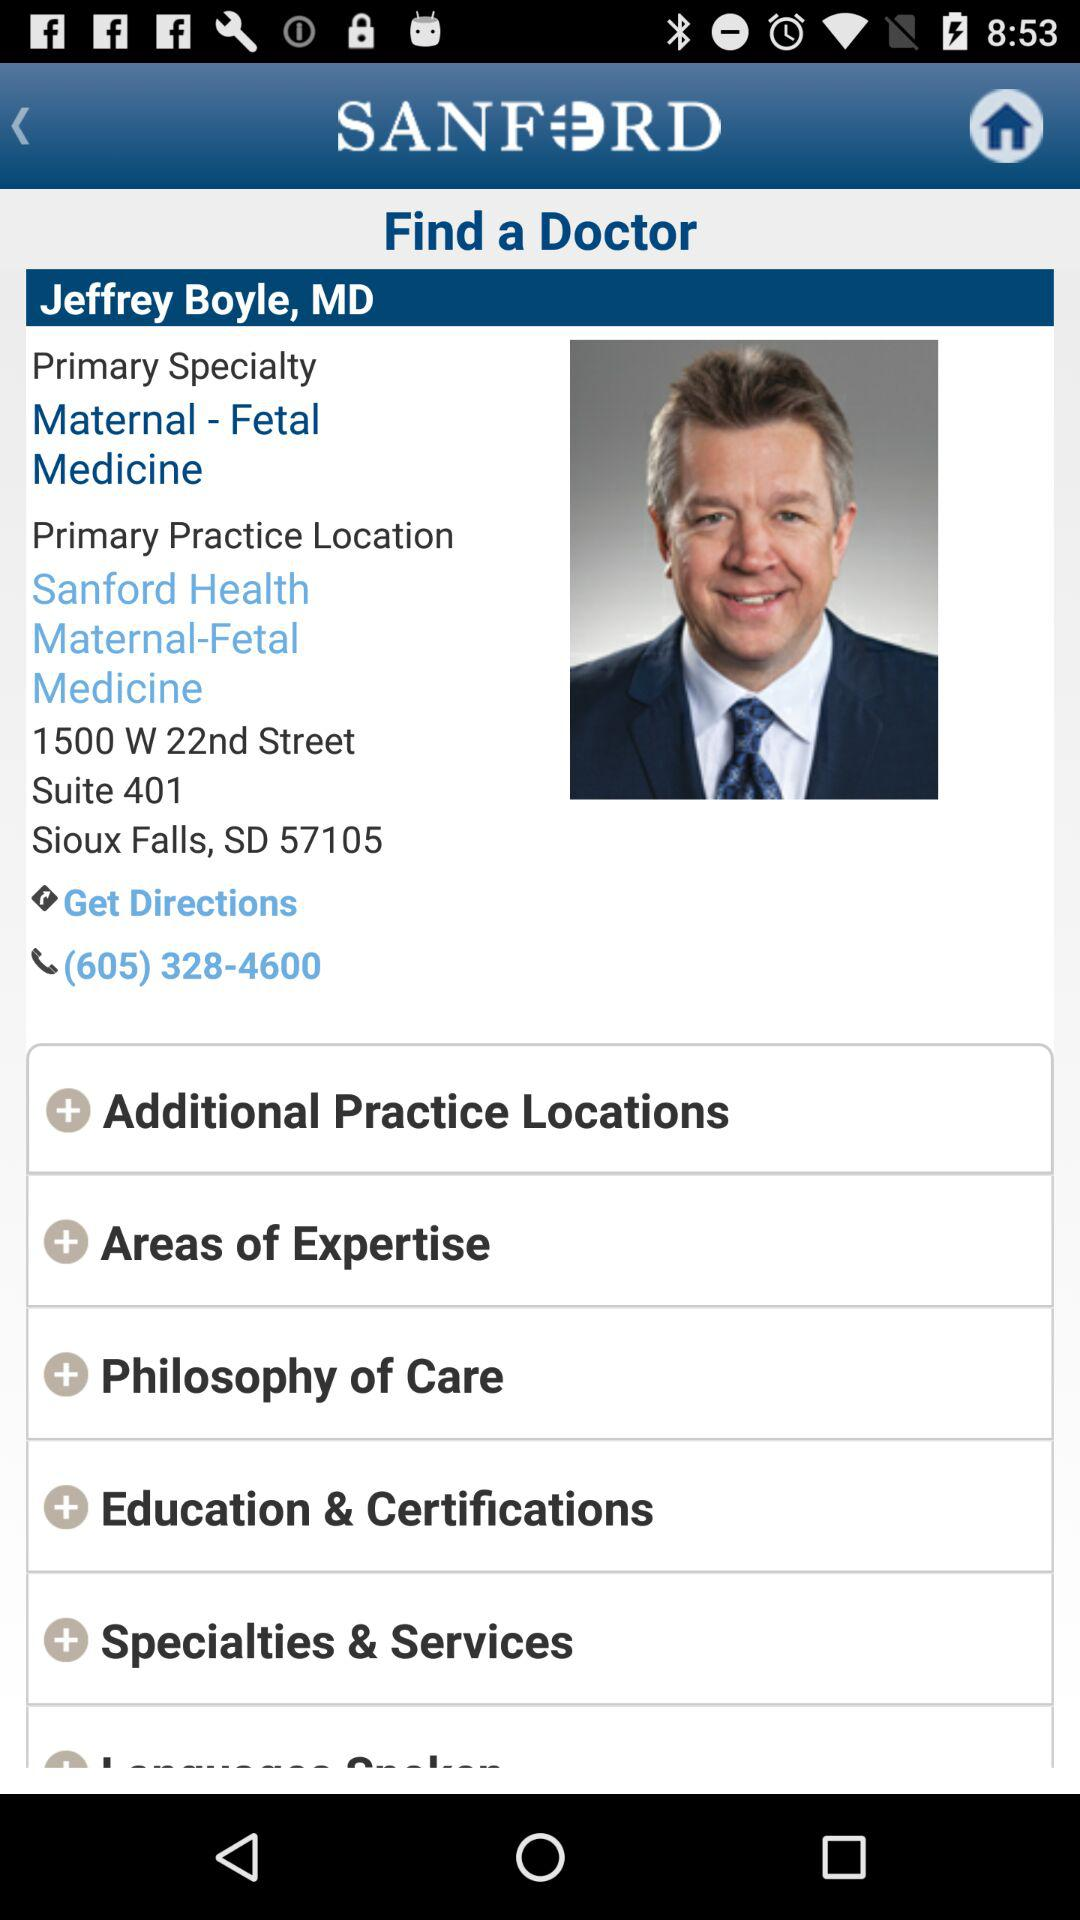What is the name of the doctor? The name of the doctor is Jeffrey Boyle. 